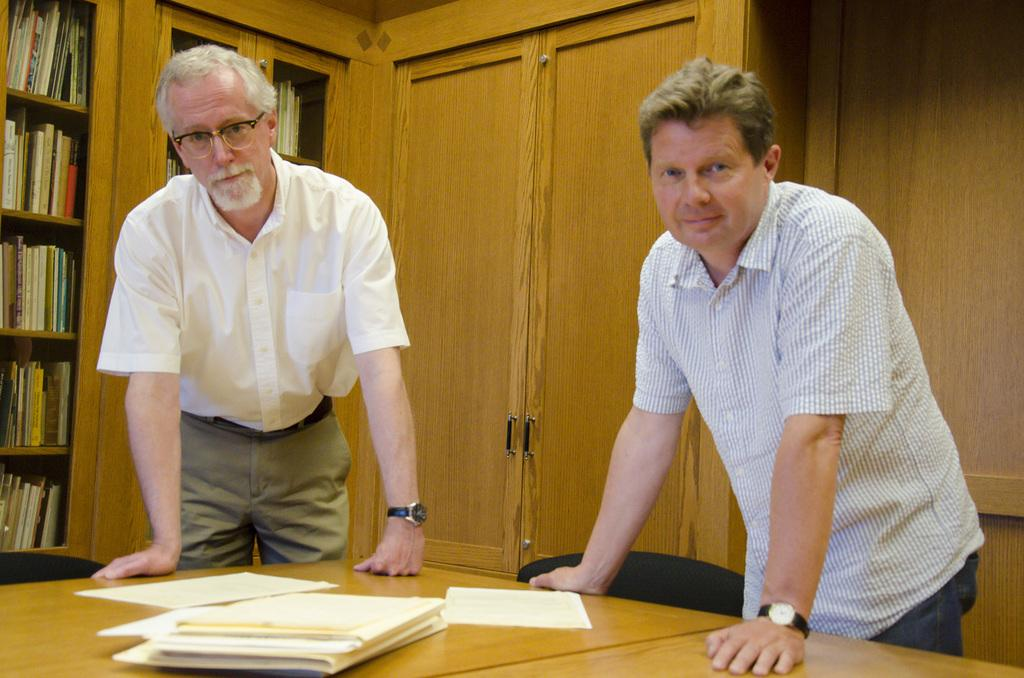How many people are present in the image? There are two men standing in the image. What objects can be seen on a surface in the image? There are papers on a table in the image. What type of furniture is present in the image? There are chairs in the image. What type of storage is present in the image? There is a bookshelf in the image. What type of cart can be seen on the sidewalk in the image? There is no cart or sidewalk present in the image. 